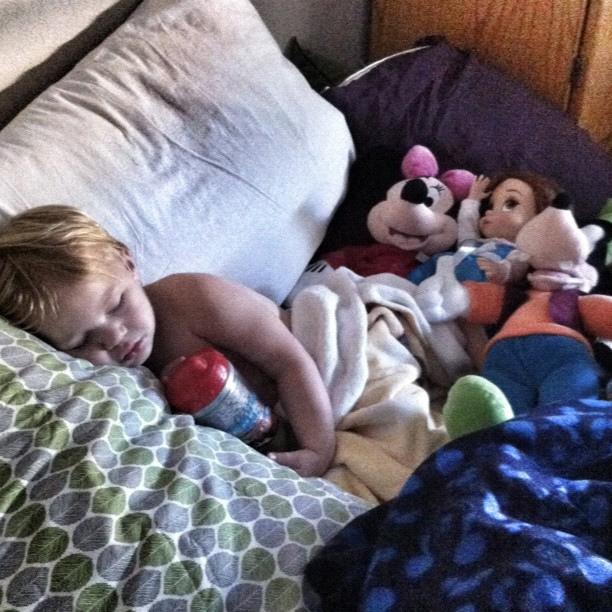How many kids are sleeping in this bed?
Give a very brief answer. 1. How many dolls are in the photo?
Give a very brief answer. 3. 